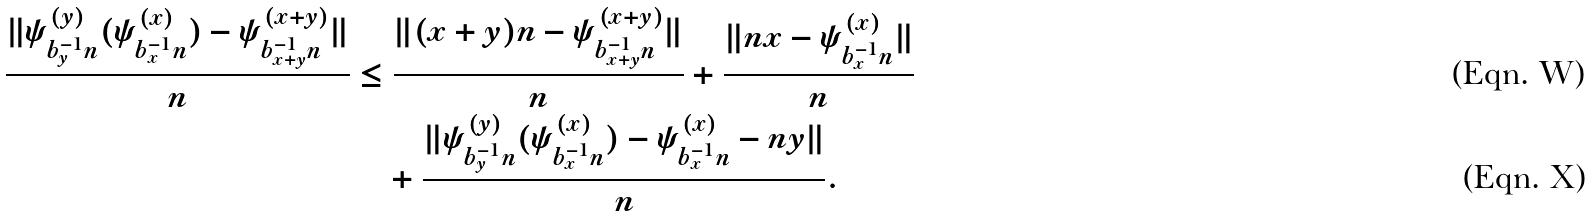Convert formula to latex. <formula><loc_0><loc_0><loc_500><loc_500>\frac { \| \psi ^ { ( y ) } _ { b _ { y } ^ { - 1 } n } ( \psi ^ { ( x ) } _ { b _ { x } ^ { - 1 } n } ) - \psi ^ { ( x + y ) } _ { b _ { x + y } ^ { - 1 } n } \| } { n } & \leq \frac { \| ( x + y ) n - \psi ^ { ( x + y ) } _ { b _ { x + y } ^ { - 1 } n } \| } { n } + \frac { \| n x - \psi ^ { ( x ) } _ { b _ { x } ^ { - 1 } n } \| } { n } \\ & \quad + \frac { \| \psi ^ { ( y ) } _ { b _ { y } ^ { - 1 } n } ( \psi ^ { ( x ) } _ { b _ { x } ^ { - 1 } n } ) - \psi ^ { ( x ) } _ { b _ { x } ^ { - 1 } n } - n y \| } { n } .</formula> 